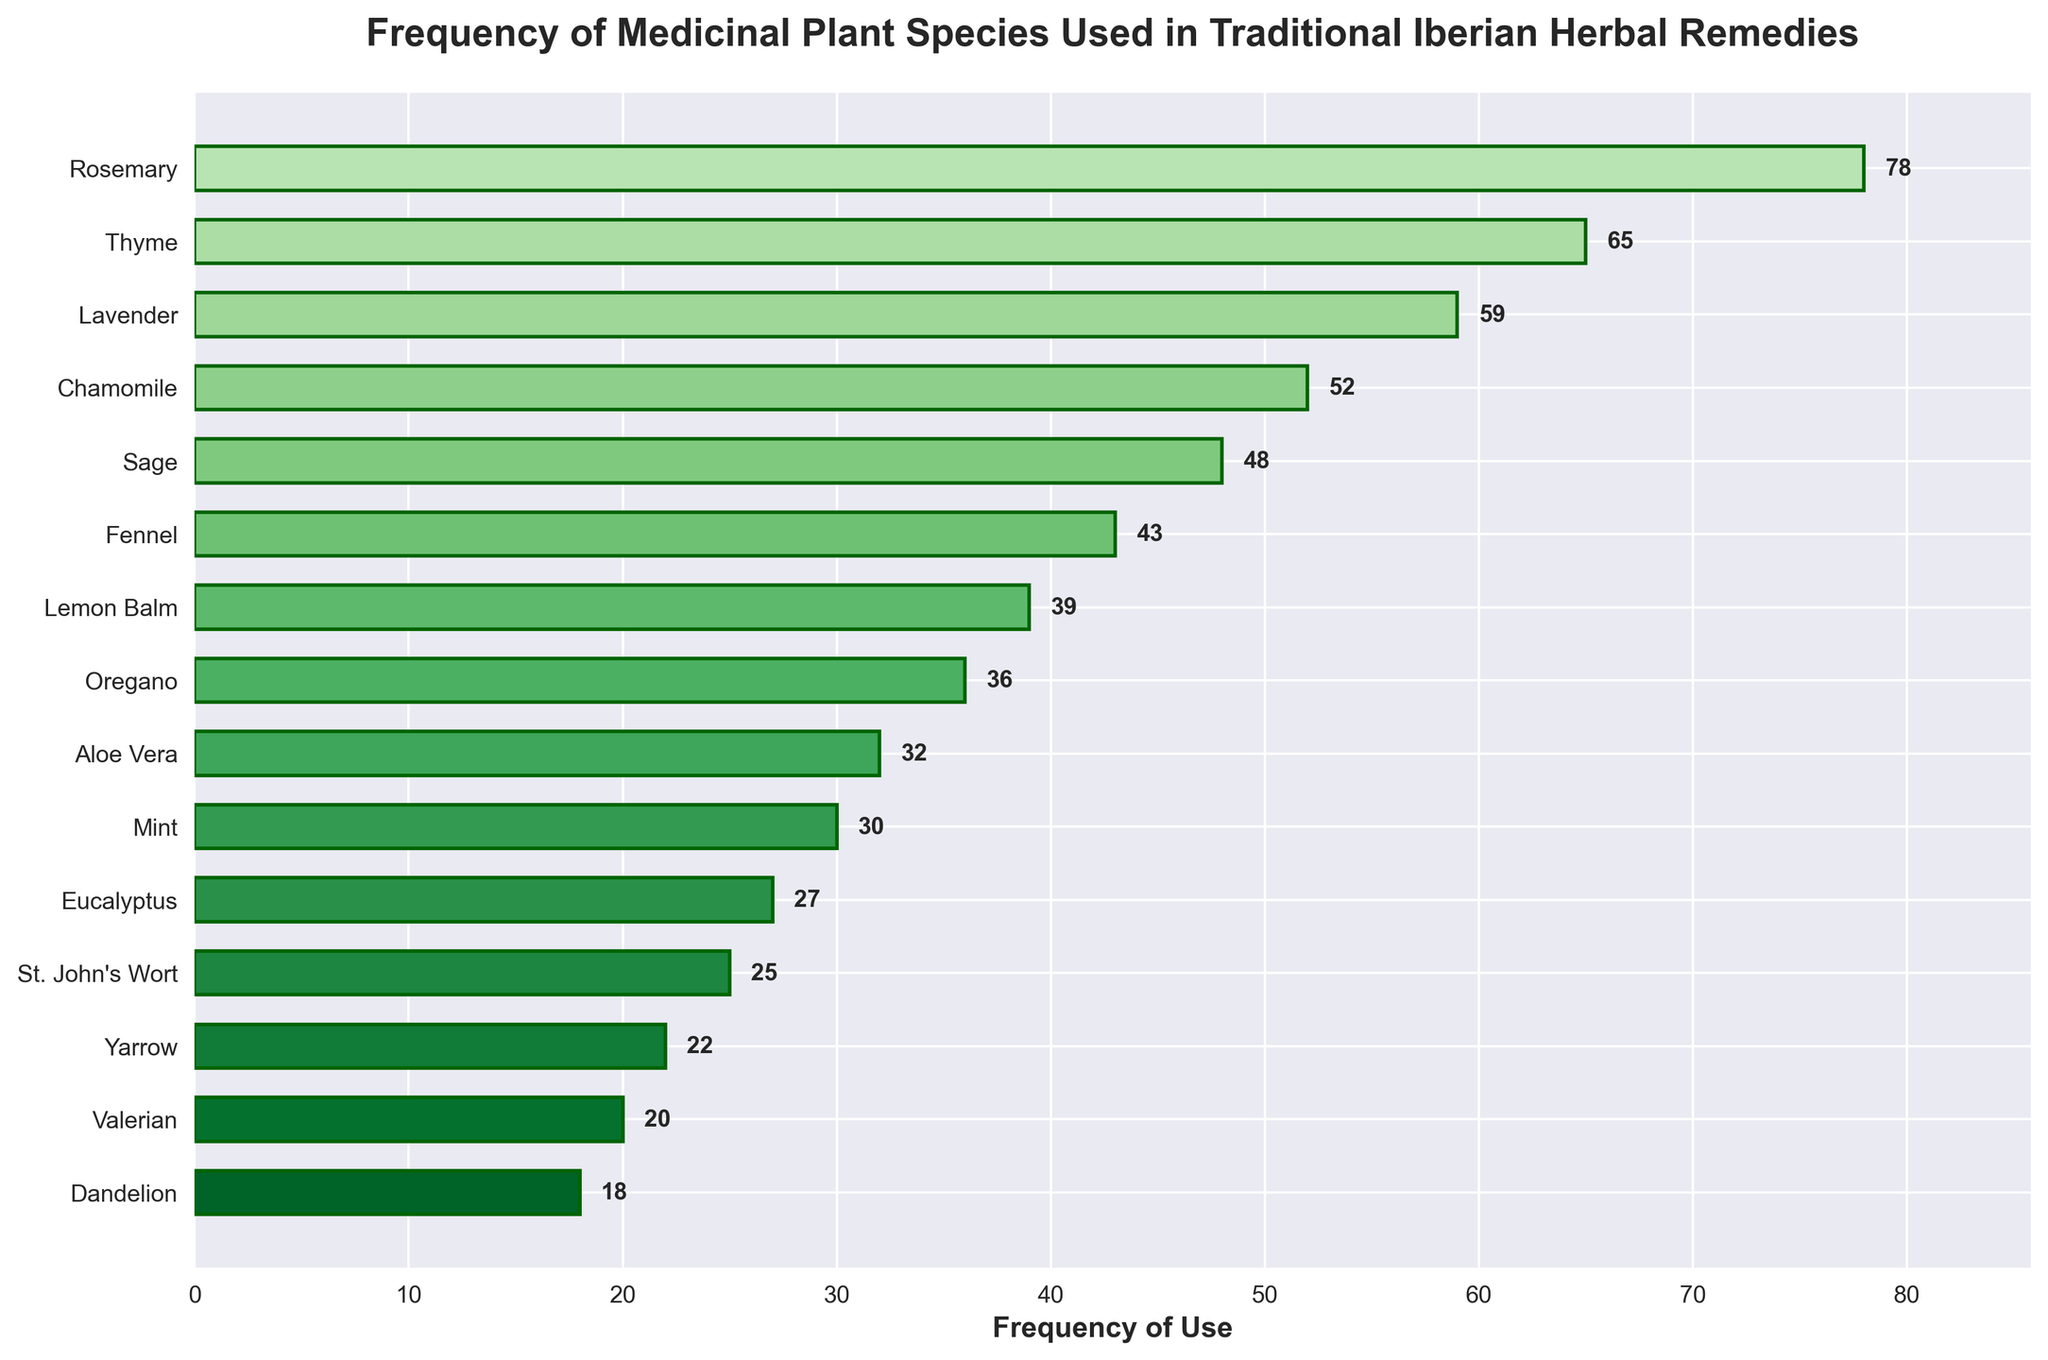Which plant species has the highest frequency of use? Identify the tallest bar in the plot. It corresponds to "Rosemary (Rosmarinus officinalis)" with a frequency of 78.
Answer: Rosemary (Rosmarinus officinalis) Which plant species has the lowest frequency of use? Identify the shortest bar in the plot. It corresponds to "Dandelion (Taraxacum officinale)" with a frequency of 18.
Answer: Dandelion (Taraxacum officinale) What is the total frequency of use for Rosemary and Lavender? Find the frequencies for Rosemary (78) and Lavender (59), then sum them: 78 + 59 = 137.
Answer: 137 Is Thyme used more frequently than Sage? Compare the heights of the bars for Thyme (65) and Sage (48). Thyme has a higher frequency.
Answer: Yes How much more frequently is Rosemary used compared to Eucalyptus? Subtract the frequency of Eucalyptus (27) from that of Rosemary (78): 78 - 27 = 51.
Answer: 51 What is the average frequency of use for Chamomile, Fennel, and Mint? Find the frequencies for Chamomile (52), Fennel (43), and Mint (30), then calculate the average: (52 + 43 + 30) / 3 ≈ 41.67.
Answer: 41.67 Which plant species have a frequency of use higher than 50? Identify bars with values greater than 50. They are Rosemary (78), Thyme (65), Lavender (59), and Chamomile (52).
Answer: Rosemary, Thyme, Lavender, Chamomile Which bar has a lighter shade of green: Oregano or Lemon Balm? Visually compare the colors. Oregano's bar (36) has a lighter shade of green compared to Lemon Balm (39).
Answer: Oregano How many plant species have a frequency of use between 20 and 40? Count the bars with frequencies falling within 20 and 40: Lemon Balm (39), Oregano (36), Aloe Vera (32), Mint (30), Eucalyptus (27). Total is 5.
Answer: 5 What is the combined frequency of use for the five least frequently used plant species? Find the frequencies for St. John's Wort (25), Yarrow (22), Valerian (20), Dandelion (18), and Eucalyptus (27), then sum them: 25 + 22 + 20 + 18 + 27 = 112.
Answer: 112 